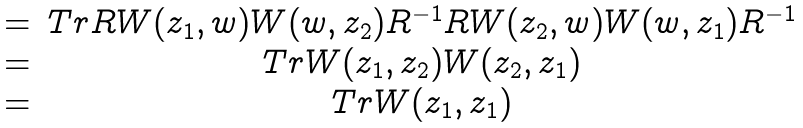Convert formula to latex. <formula><loc_0><loc_0><loc_500><loc_500>\begin{array} { c c } = & T r R W ( z _ { 1 } , w ) W ( w , z _ { 2 } ) R ^ { - 1 } R W ( z _ { 2 } , w ) W ( w , z _ { 1 } ) R ^ { - 1 } \\ = & T r W ( z _ { 1 } , z _ { 2 } ) W ( z _ { 2 } , z _ { 1 } ) \\ = & T r W ( z _ { 1 } , z _ { 1 } ) \end{array}</formula> 